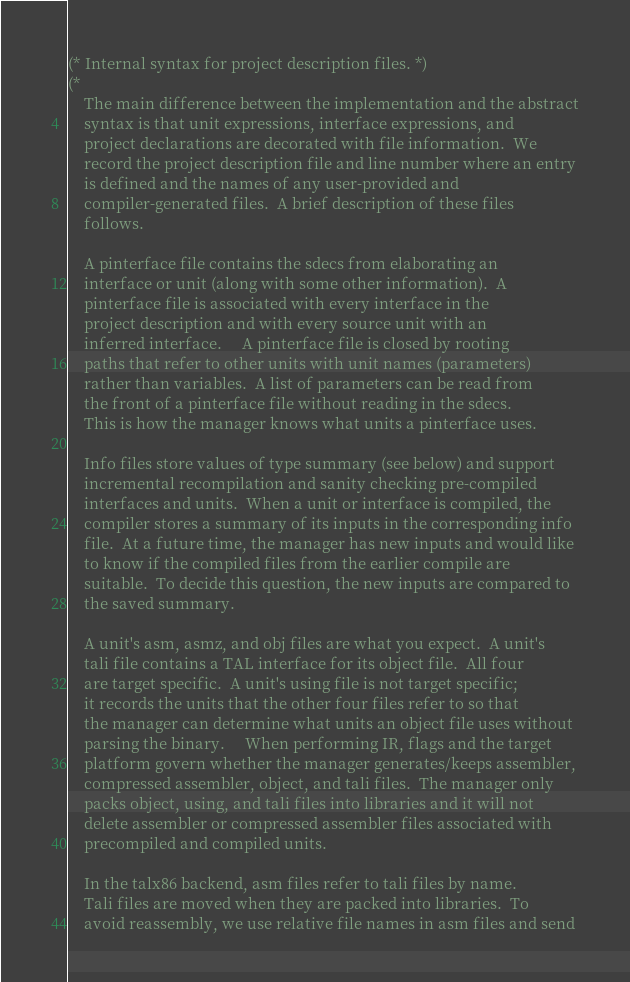Convert code to text. <code><loc_0><loc_0><loc_500><loc_500><_SML_>(* Internal syntax for project description files. *)
(*
    The main difference between the implementation and the abstract
    syntax is that unit expressions, interface expressions, and
    project declarations are decorated with file information.  We
    record the project description file and line number where an entry
    is defined and the names of any user-provided and
    compiler-generated files.  A brief description of these files
    follows.

    A pinterface file contains the sdecs from elaborating an
    interface or unit (along with some other information).  A
    pinterface file is associated with every interface in the
    project description and with every source unit with an
    inferred interface.	 A pinterface file is closed by rooting
    paths that refer to other units with unit names (parameters)
    rather than variables.  A list of parameters can be read from
    the front of a pinterface file without reading in the sdecs.
    This is how the manager knows what units a pinterface uses.

    Info files store values of type summary (see below) and support
    incremental recompilation and sanity checking pre-compiled
    interfaces and units.  When a unit or interface is compiled, the
    compiler stores a summary of its inputs in the corresponding info
    file.  At a future time, the manager has new inputs and would like
    to know if the compiled files from the earlier compile are
    suitable.  To decide this question, the new inputs are compared to
    the saved summary.

    A unit's asm, asmz, and obj files are what you expect.  A unit's
    tali file contains a TAL interface for its object file.  All four
    are target specific.  A unit's using file is not target specific;
    it records the units that the other four files refer to so that
    the manager can determine what units an object file uses without
    parsing the binary.	 When performing IR, flags and the target
    platform govern whether the manager generates/keeps assembler,
    compressed assembler, object, and tali files.  The manager only
    packs object, using, and tali files into libraries and it will not
    delete assembler or compressed assembler files associated with
    precompiled and compiled units.

    In the talx86 backend, asm files refer to tali files by name.
    Tali files are moved when they are packed into libraries.  To
    avoid reassembly, we use relative file names in asm files and send</code> 